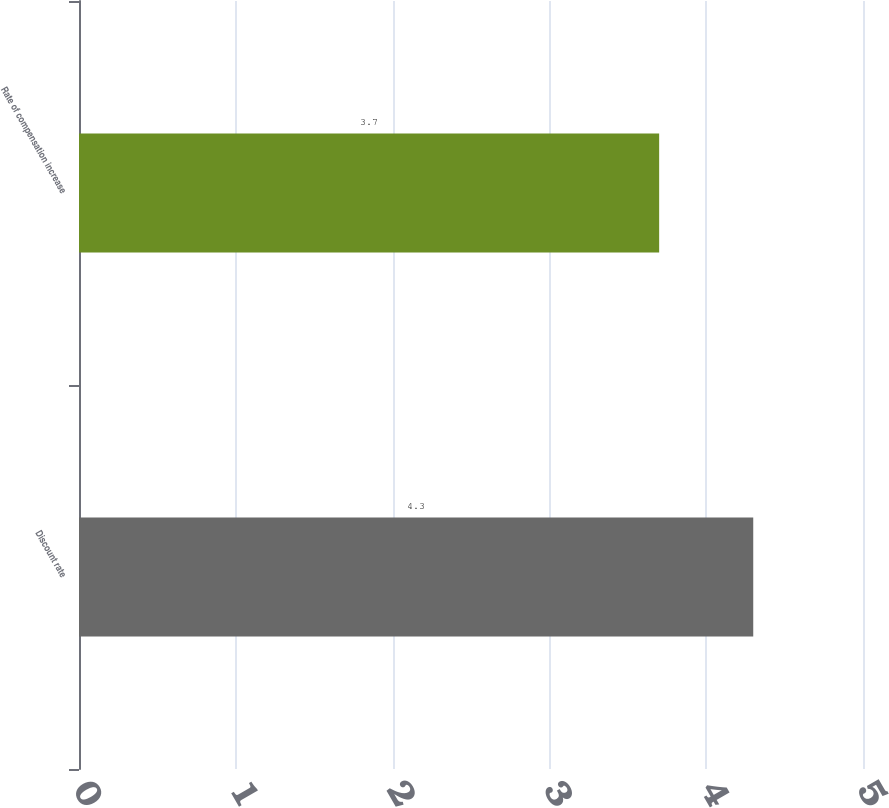<chart> <loc_0><loc_0><loc_500><loc_500><bar_chart><fcel>Discount rate<fcel>Rate of compensation increase<nl><fcel>4.3<fcel>3.7<nl></chart> 